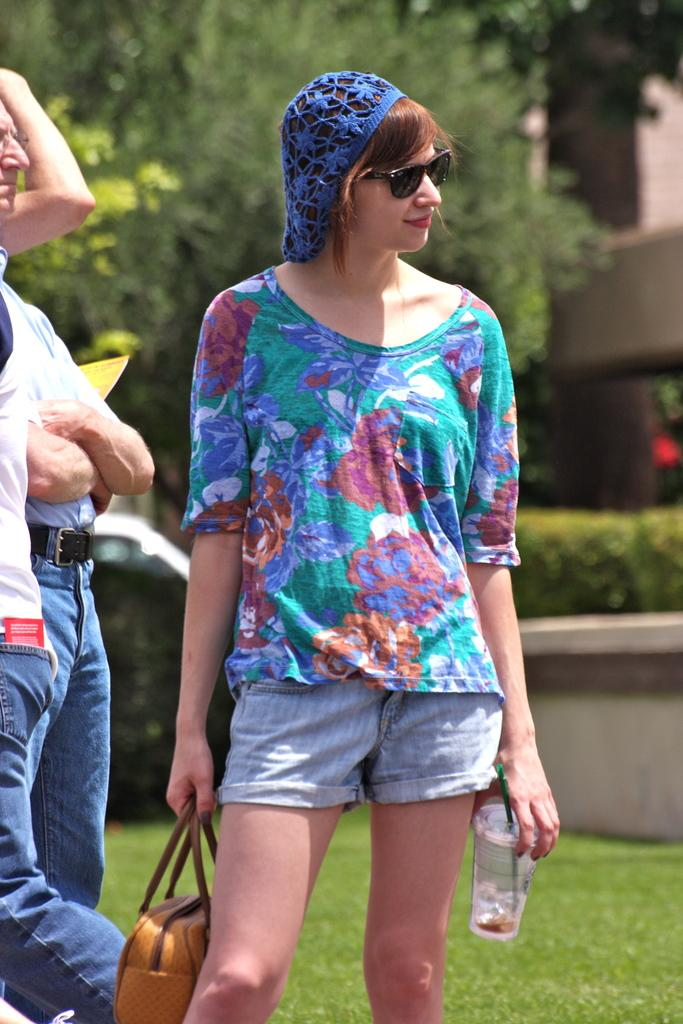How many people are in the image? There are three persons standing in the image. What is the surface they are standing on? The persons are standing on the grass. What can be seen in the background of the image? There are trees and a building in the background of the image. What type of drain is visible in the image? There is no drain present in the image. Can you describe the position of the locket on the person's neck in the image? There is no locket visible on any of the persons in the image. 